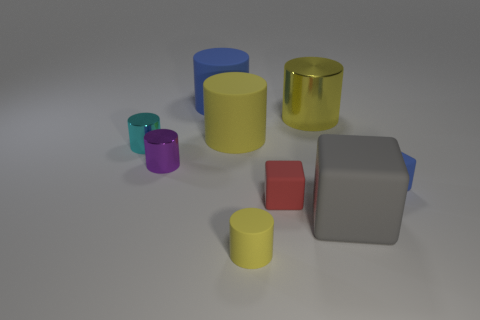Subtract all green balls. How many yellow cylinders are left? 3 Subtract 1 cylinders. How many cylinders are left? 5 Subtract all blue cylinders. How many cylinders are left? 5 Subtract all big yellow cylinders. How many cylinders are left? 4 Subtract all purple cylinders. Subtract all purple cubes. How many cylinders are left? 5 Add 1 green cylinders. How many objects exist? 10 Subtract all cylinders. How many objects are left? 3 Subtract 0 brown blocks. How many objects are left? 9 Subtract all large gray things. Subtract all small blue cubes. How many objects are left? 7 Add 1 tiny objects. How many tiny objects are left? 6 